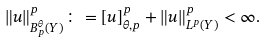<formula> <loc_0><loc_0><loc_500><loc_500>\| u \| _ { B ^ { \theta } _ { p } ( Y ) } ^ { p } \colon = [ u ] _ { \theta , p } ^ { p } + \| u \| _ { L ^ { p } ( Y ) } ^ { p } < \infty .</formula> 